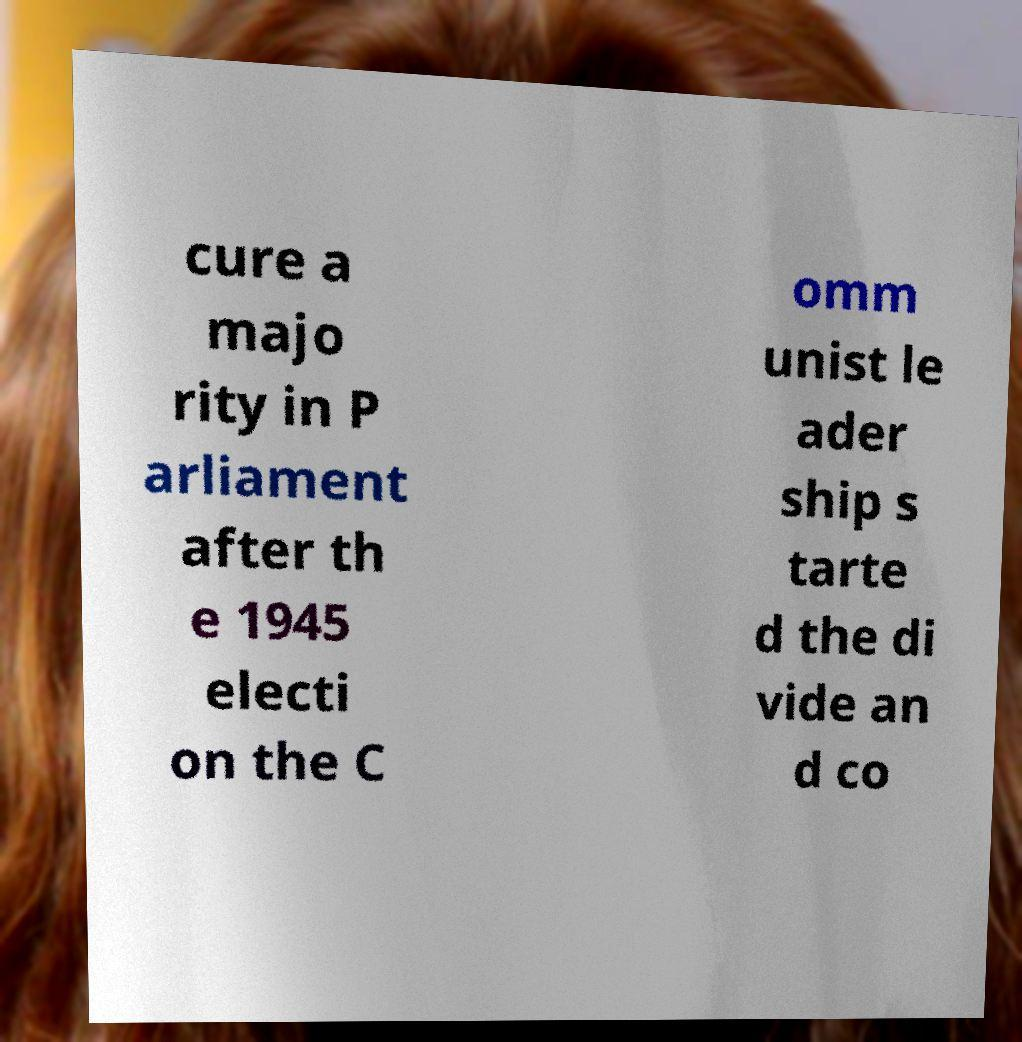There's text embedded in this image that I need extracted. Can you transcribe it verbatim? cure a majo rity in P arliament after th e 1945 electi on the C omm unist le ader ship s tarte d the di vide an d co 